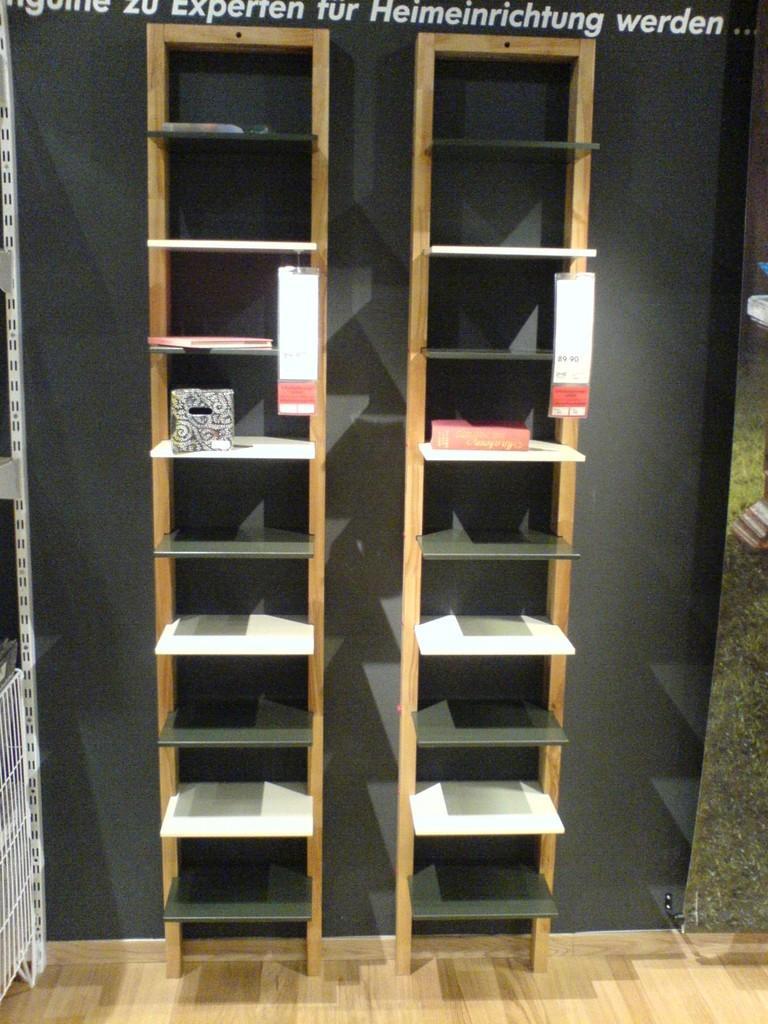Could you give a brief overview of what you see in this image? In this picture we can see wooden racks, on which we can see the cotton box and papers. At the top there is a watermark. At the bottom there is a wooden floor. 